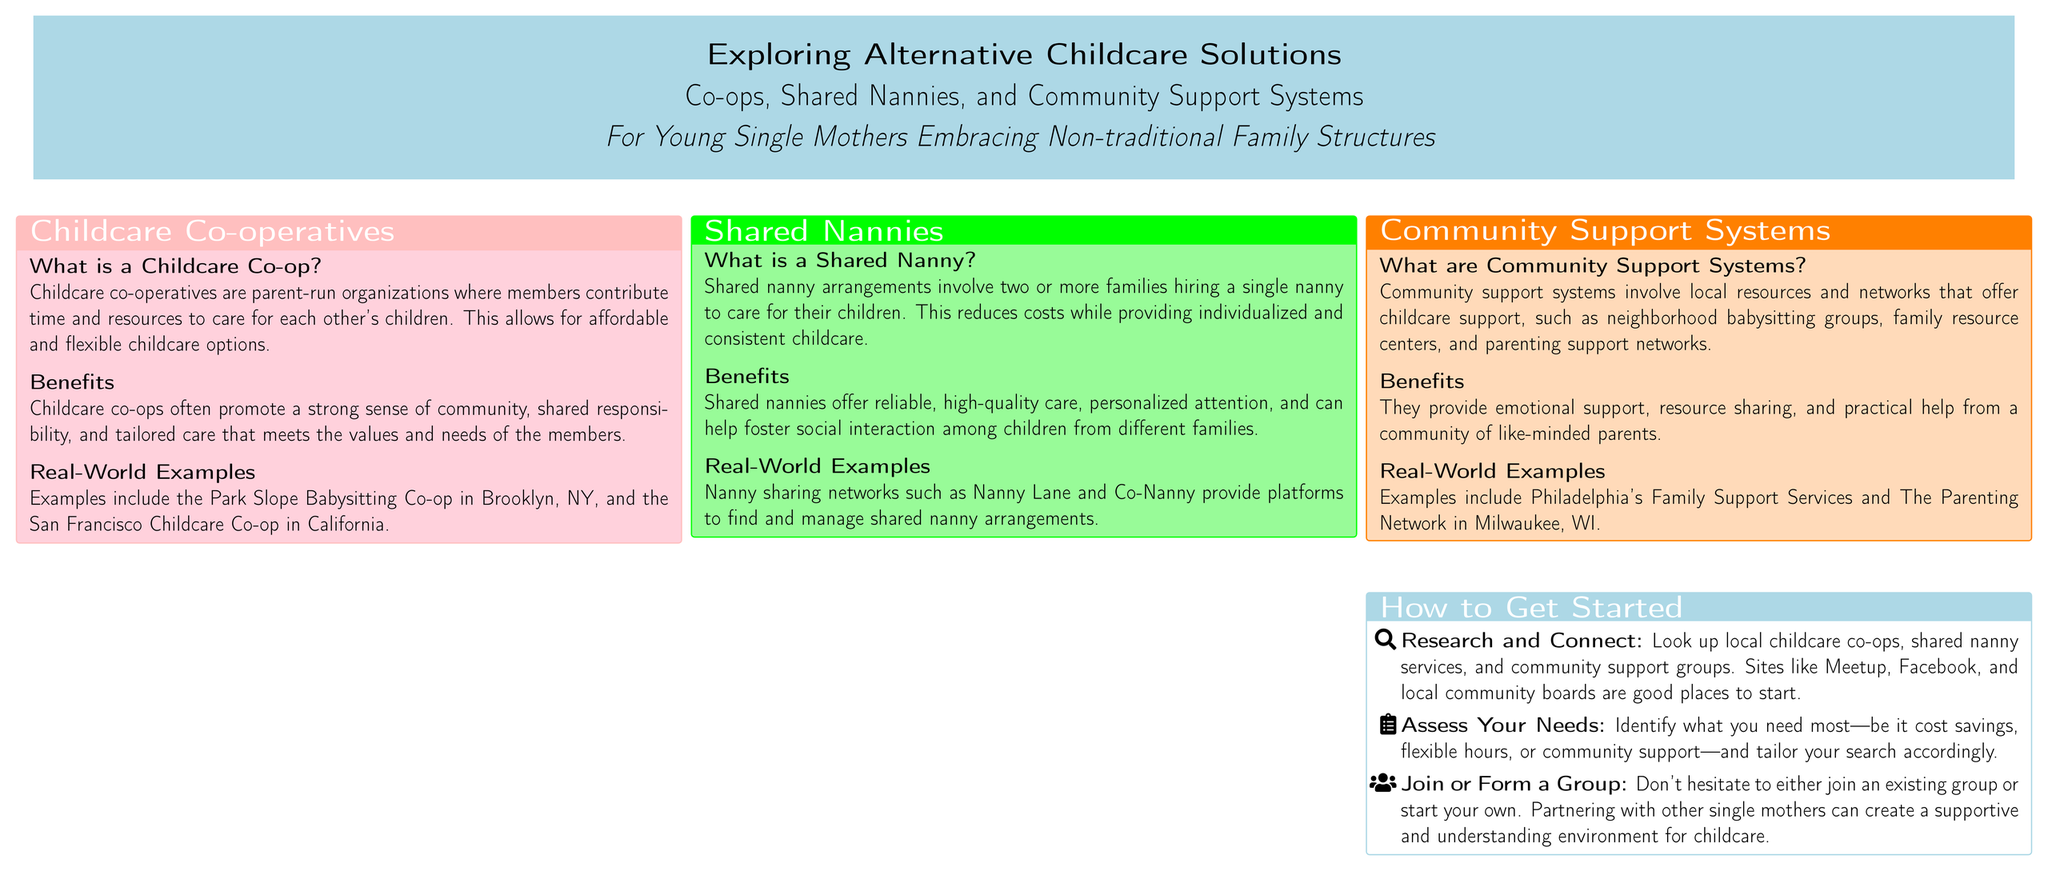What is a Childcare Co-op? A Childcare Co-op is a parent-run organization where members contribute time and resources to care for each other's children.
Answer: Parent-run organization What are the benefits of Shared Nannies? Shared Nannies offer reliable, high-quality care, personalized attention, and can help foster social interaction among children from different families.
Answer: Reliable, high-quality care What is an example of a Childcare Co-op? An example of a Childcare Co-op is the Park Slope Babysitting Co-op in Brooklyn, NY.
Answer: Park Slope Babysitting Co-op What should you do first to get started? To get started, you should research and connect with local childcare co-ops, shared nanny services, and community support groups.
Answer: Research and connect Who is the target audience for this poster? The target audience for this poster is young single mothers embracing non-traditional family structures.
Answer: Young single mothers What do Community Support Systems provide? Community Support Systems provide emotional support, resource sharing, and practical help from a community of like-minded parents.
Answer: Emotional support What should you assess before joining a childcare group? You should assess what you need most—be it cost savings, flexible hours, or community support.
Answer: Your needs What is a real-world example of a Community Support System? An example of a Community Support System is Philadelphia's Family Support Services.
Answer: Philadelphia's Family Support Services 